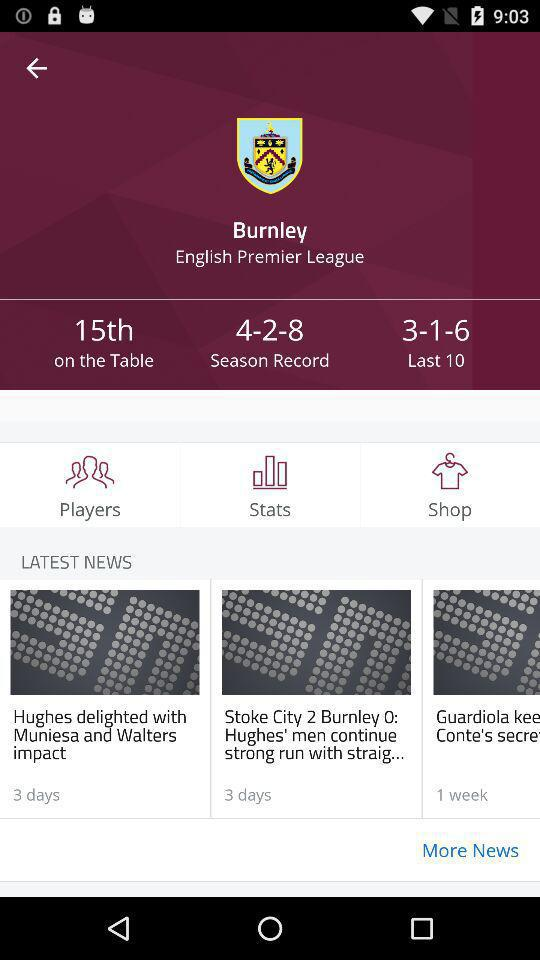What's the season record? The season record is 4-2-8. 